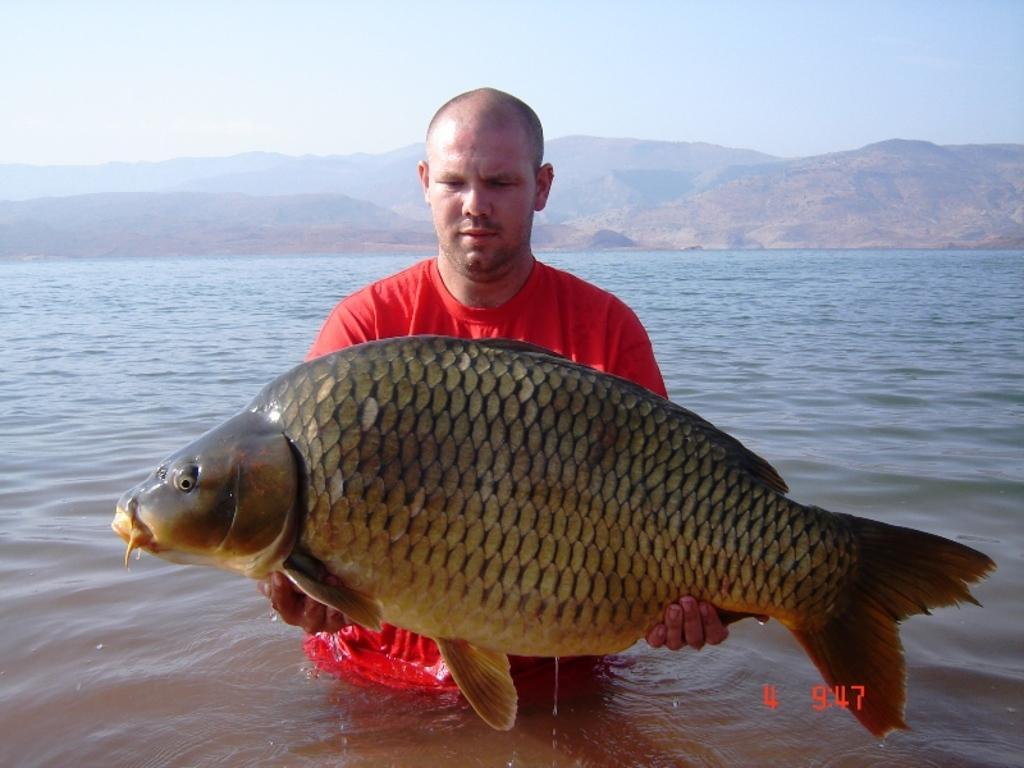In one or two sentences, can you explain what this image depicts? In the foreground I can see a man is holding a fish in hand. In the background I can see water, mountains and the sky. This image is taken may be near the lake. 